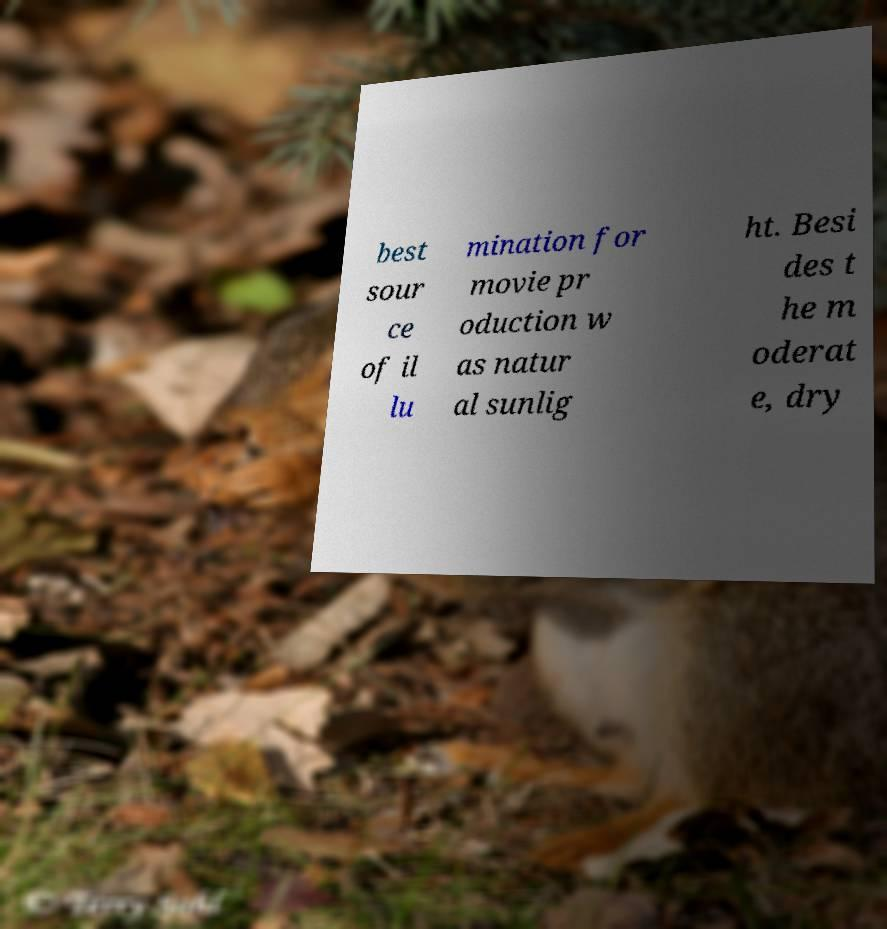There's text embedded in this image that I need extracted. Can you transcribe it verbatim? best sour ce of il lu mination for movie pr oduction w as natur al sunlig ht. Besi des t he m oderat e, dry 